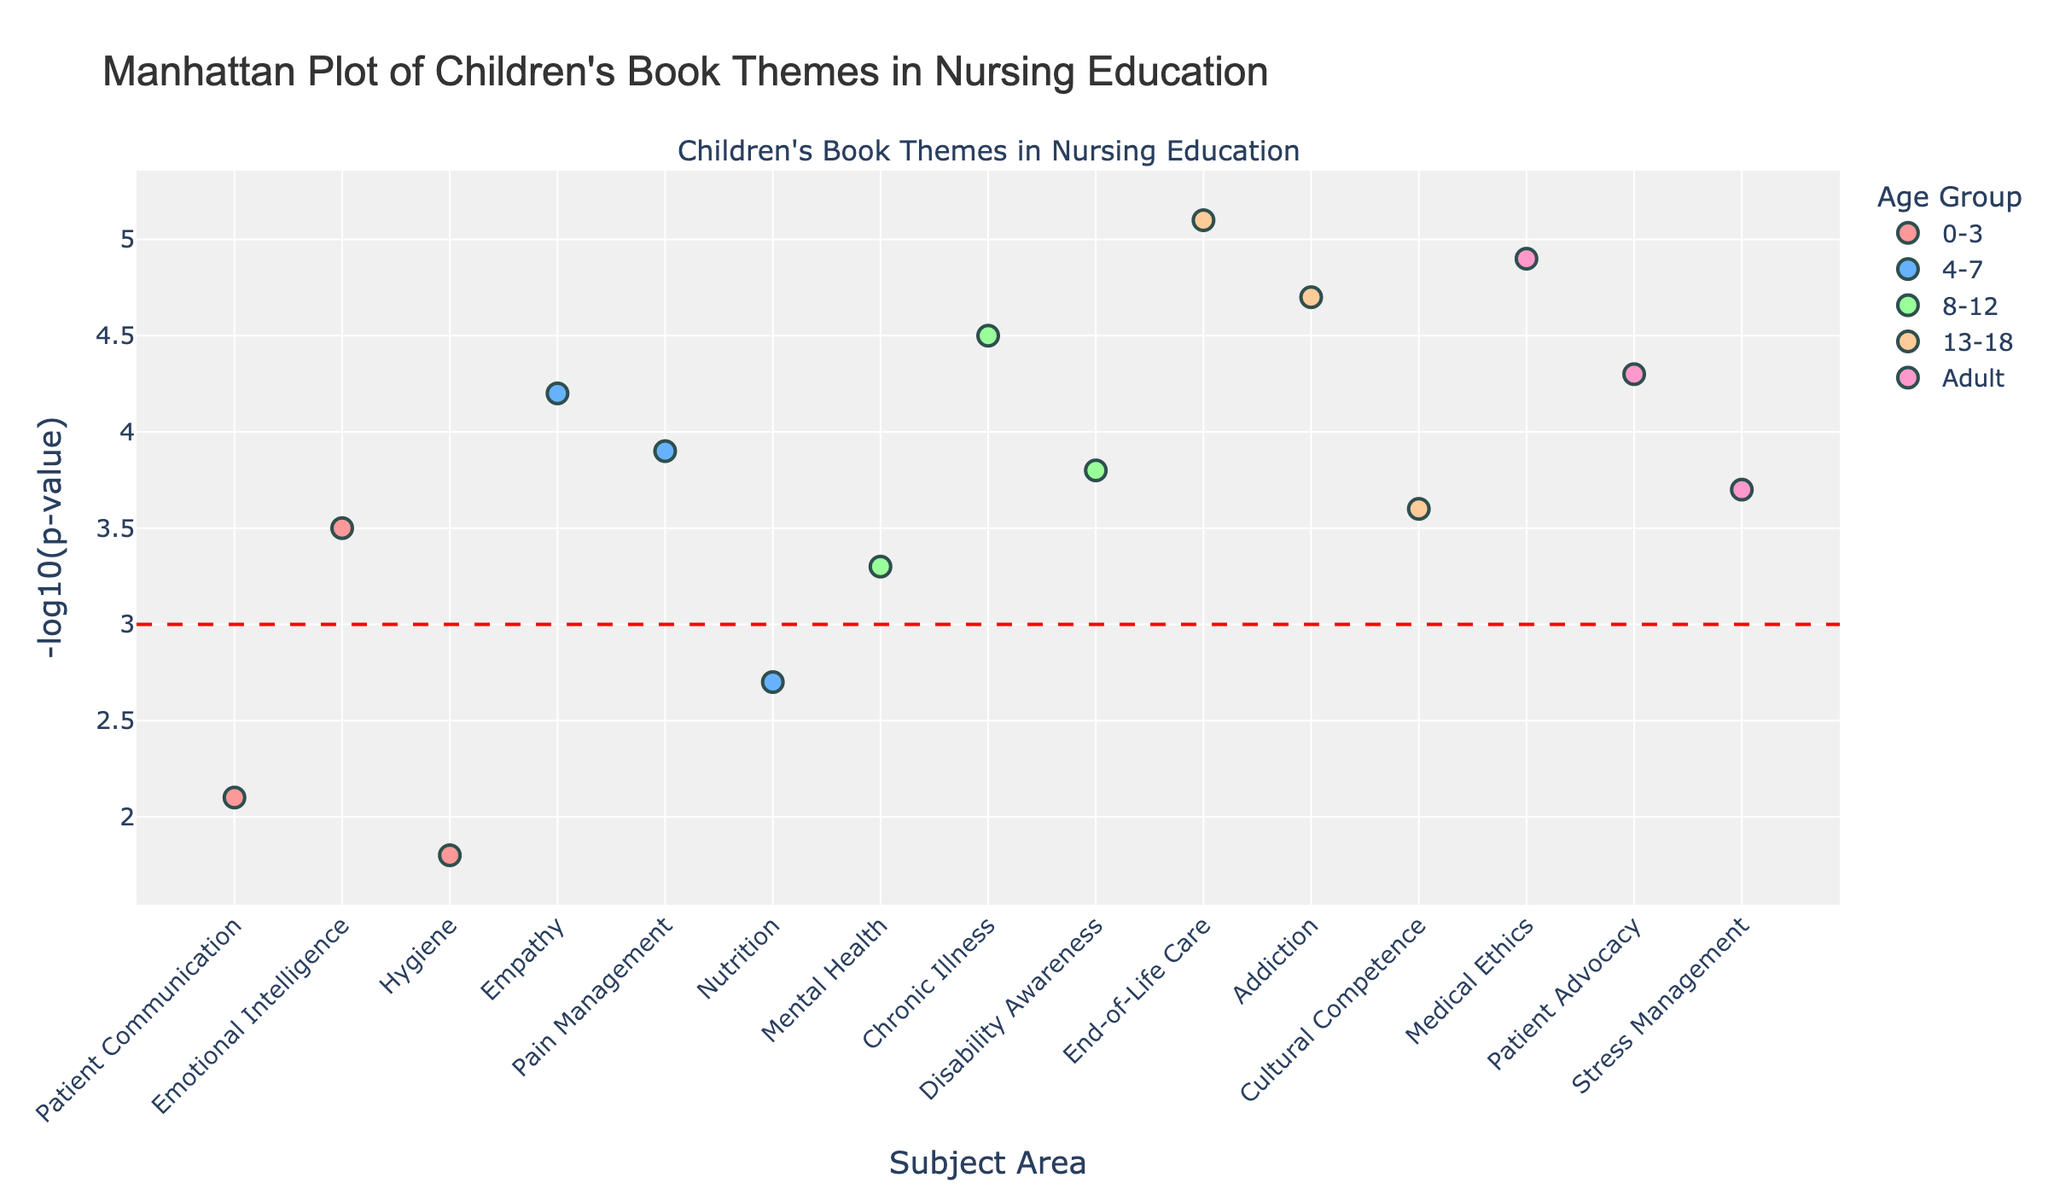What is the title of the plot? The title is clearly shown at the top of the plot.
Answer: Manhattan Plot of Children's Book Themes in Nursing Education Which age group has the largest number of data points? By counting the number of markers for each age group, we can see that the age group 8-12 has the most data points with three.
Answer: 8-12 What is the -log10(p-value) for the theme "Loss" in age group 13-18? Look for the marker with the theme "Loss" in the age group 13-18 and read off its -log10(p-value). It is 5.1.
Answer: 5.1 Which subject area for the age group 4-7 has the highest -log10(p-value)? Identify the subject areas within the age group 4-7 and compare their -log10(p-values). The subject area "Empathy" with theme "Kindness" has the highest -log10(p-value) of 4.2.
Answer: Empathy Are any themes below the threshold -log10(p-value) of 3 for the age group 0-3? Observe the markers for age group 0-3 and see if any are below the threshold line set at a -log10(p-value) of 3. The themes "Sharing" and "Cleanliness" are below this threshold.
Answer: Yes How many themes have a -log10(p-value) higher than 3.5 across all age groups? Count the number of markers across all age groups that have a value higher than 3.5 for -log10(p-value). There are seven themes: "Feelings" (0-3), "Kindness" (4-7), "Bravery" (4-7), "Friendship" (8-12), "Perseverance" (8-12), "Loss" (13-18), and "Honesty" (Adult).
Answer: 7 Which age group has the highest overall -log10(p-value) and what is the corresponding theme? Identify the marker with the highest -log10(p-value) across all age groups, which is 5.1 for the theme "Loss" in the age group 13-18.
Answer: 13-18, Loss Compare the -log10(p-value) for the theme "Healthy Eating" in age group 4-7 with the theme "Mindfulness" in the Adult age group. Which one is higher? Look at the -log10(p(values) for "Healthy Eating" (2.7) and "Mindfulness" (3.7) and compare them. "Mindfulness" has a higher -log10(p-value).
Answer: Mindfulness What is the subject area associated with the theme "Friendship" in the age group 8-12? Find the marker for the theme "Friendship" in the age group 8-12, which corresponds to the subject area "Mental Health."
Answer: Mental Health Which age group has the theme "Standing Up" and what is its -log10(p-value)? Locate the marker with the theme "Standing Up" in the age group Adult, having a -log10(p-value) of 4.3.
Answer: Adult, 4.3 